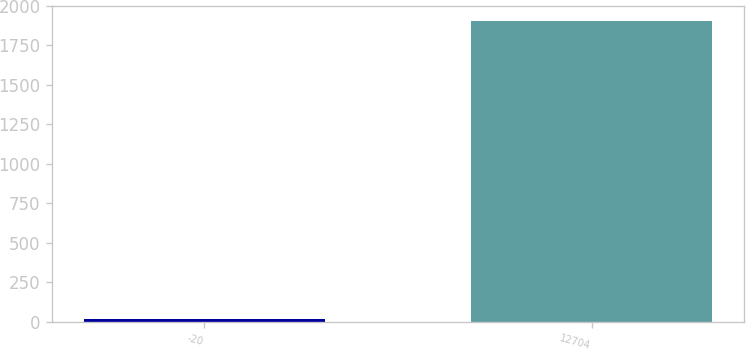Convert chart. <chart><loc_0><loc_0><loc_500><loc_500><bar_chart><fcel>-20<fcel>12704<nl><fcel>20<fcel>1905.6<nl></chart> 